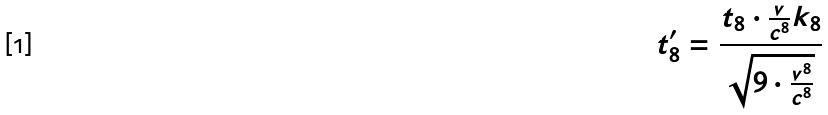Convert formula to latex. <formula><loc_0><loc_0><loc_500><loc_500>t _ { 8 } ^ { \prime } = \frac { t _ { 8 } \cdot \frac { v } { c ^ { 8 } } k _ { 8 } } { \sqrt { 9 \cdot \frac { v ^ { 8 } } { c ^ { 8 } } } }</formula> 